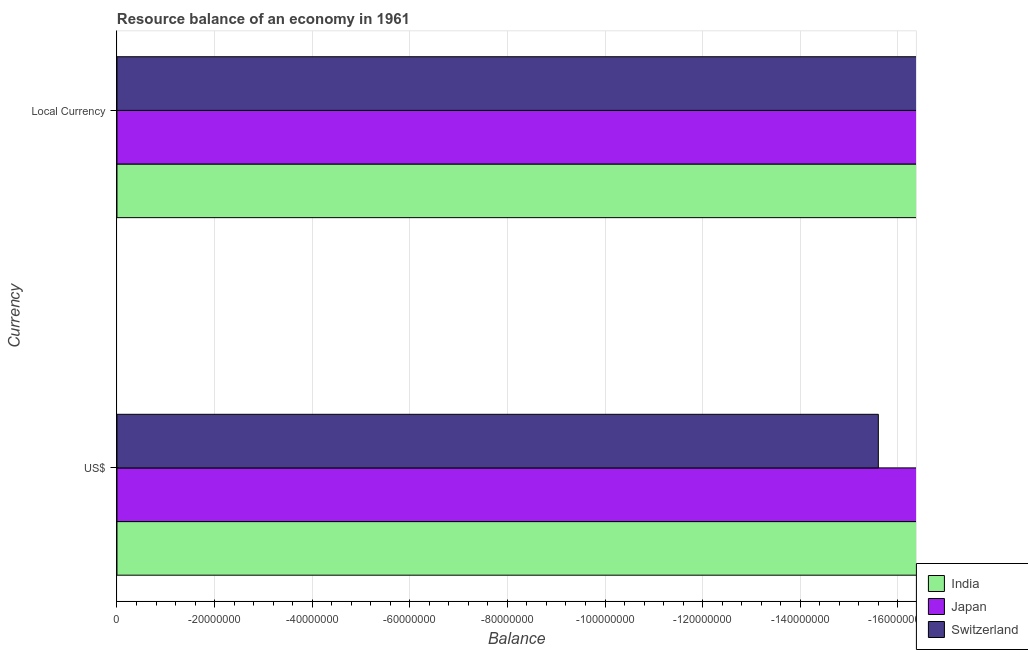How many bars are there on the 2nd tick from the bottom?
Give a very brief answer. 0. What is the label of the 1st group of bars from the top?
Your answer should be compact. Local Currency. What is the total resource balance in constant us$ in the graph?
Your response must be concise. 0. What is the difference between the resource balance in constant us$ in India and the resource balance in us$ in Japan?
Ensure brevity in your answer.  0. What is the average resource balance in constant us$ per country?
Your answer should be compact. 0. In how many countries, is the resource balance in us$ greater than the average resource balance in us$ taken over all countries?
Ensure brevity in your answer.  0. How many bars are there?
Provide a succinct answer. 0. How many countries are there in the graph?
Provide a short and direct response. 3. What is the difference between two consecutive major ticks on the X-axis?
Your answer should be very brief. 2.00e+07. How many legend labels are there?
Your answer should be very brief. 3. What is the title of the graph?
Make the answer very short. Resource balance of an economy in 1961. Does "Ethiopia" appear as one of the legend labels in the graph?
Your answer should be very brief. No. What is the label or title of the X-axis?
Provide a succinct answer. Balance. What is the label or title of the Y-axis?
Give a very brief answer. Currency. What is the Balance in India in US$?
Make the answer very short. 0. What is the Balance of Switzerland in US$?
Keep it short and to the point. 0. What is the Balance of Japan in Local Currency?
Keep it short and to the point. 0. What is the Balance in Switzerland in Local Currency?
Provide a short and direct response. 0. What is the average Balance in India per Currency?
Offer a very short reply. 0. What is the average Balance of Switzerland per Currency?
Make the answer very short. 0. 